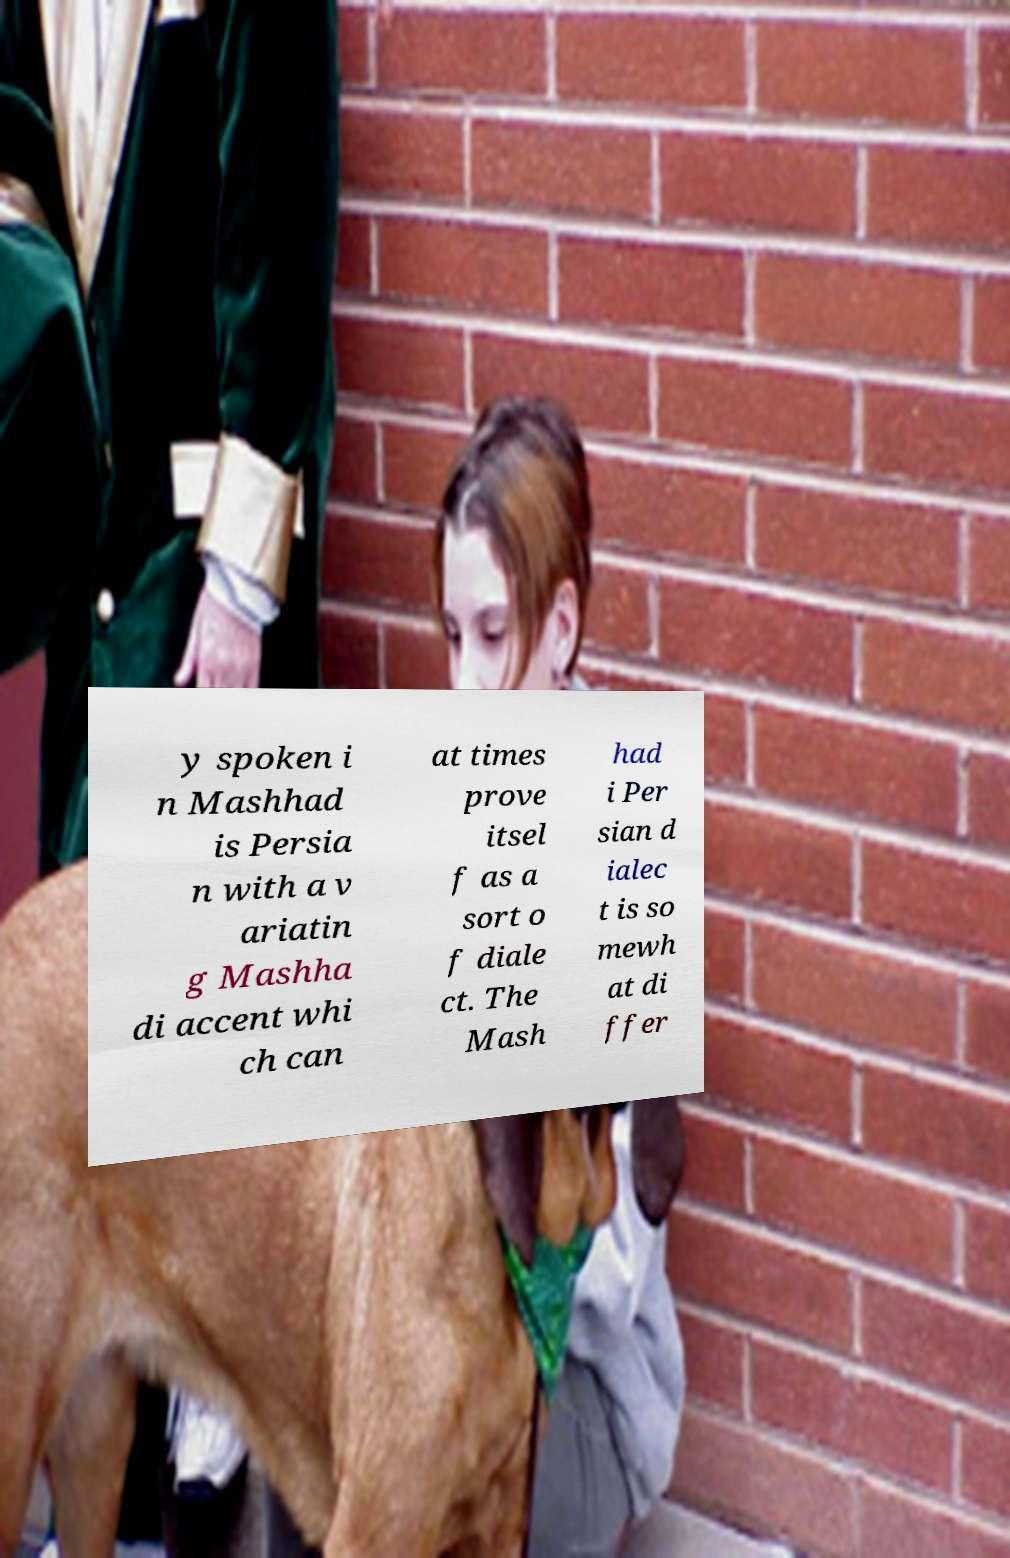Can you accurately transcribe the text from the provided image for me? y spoken i n Mashhad is Persia n with a v ariatin g Mashha di accent whi ch can at times prove itsel f as a sort o f diale ct. The Mash had i Per sian d ialec t is so mewh at di ffer 